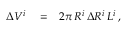<formula> <loc_0><loc_0><loc_500><loc_500>\begin{array} { r l r } { \Delta V ^ { i } } & = } & { 2 \pi \, R ^ { i } \, \Delta R ^ { i } \, L ^ { i } \, , } \end{array}</formula> 